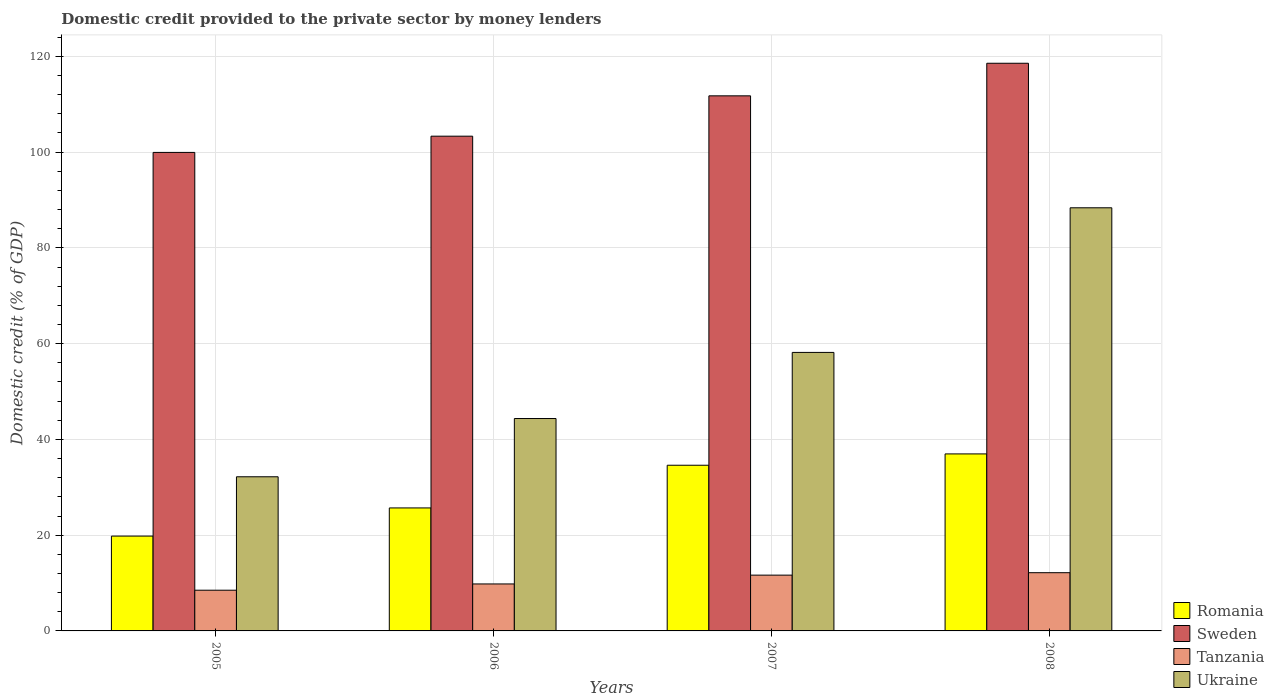How many groups of bars are there?
Your answer should be compact. 4. Are the number of bars per tick equal to the number of legend labels?
Keep it short and to the point. Yes. Are the number of bars on each tick of the X-axis equal?
Give a very brief answer. Yes. How many bars are there on the 4th tick from the right?
Your answer should be very brief. 4. What is the label of the 1st group of bars from the left?
Offer a very short reply. 2005. What is the domestic credit provided to the private sector by money lenders in Sweden in 2008?
Provide a succinct answer. 118.57. Across all years, what is the maximum domestic credit provided to the private sector by money lenders in Tanzania?
Offer a terse response. 12.16. Across all years, what is the minimum domestic credit provided to the private sector by money lenders in Ukraine?
Give a very brief answer. 32.2. In which year was the domestic credit provided to the private sector by money lenders in Romania minimum?
Offer a very short reply. 2005. What is the total domestic credit provided to the private sector by money lenders in Romania in the graph?
Give a very brief answer. 117.07. What is the difference between the domestic credit provided to the private sector by money lenders in Tanzania in 2005 and that in 2007?
Make the answer very short. -3.15. What is the difference between the domestic credit provided to the private sector by money lenders in Sweden in 2008 and the domestic credit provided to the private sector by money lenders in Romania in 2006?
Provide a succinct answer. 92.88. What is the average domestic credit provided to the private sector by money lenders in Sweden per year?
Provide a short and direct response. 108.4. In the year 2006, what is the difference between the domestic credit provided to the private sector by money lenders in Romania and domestic credit provided to the private sector by money lenders in Ukraine?
Provide a succinct answer. -18.68. In how many years, is the domestic credit provided to the private sector by money lenders in Romania greater than 80 %?
Offer a very short reply. 0. What is the ratio of the domestic credit provided to the private sector by money lenders in Romania in 2005 to that in 2008?
Ensure brevity in your answer.  0.54. Is the difference between the domestic credit provided to the private sector by money lenders in Romania in 2005 and 2006 greater than the difference between the domestic credit provided to the private sector by money lenders in Ukraine in 2005 and 2006?
Your answer should be very brief. Yes. What is the difference between the highest and the second highest domestic credit provided to the private sector by money lenders in Romania?
Your answer should be very brief. 2.37. What is the difference between the highest and the lowest domestic credit provided to the private sector by money lenders in Romania?
Provide a short and direct response. 17.16. Is it the case that in every year, the sum of the domestic credit provided to the private sector by money lenders in Sweden and domestic credit provided to the private sector by money lenders in Romania is greater than the sum of domestic credit provided to the private sector by money lenders in Ukraine and domestic credit provided to the private sector by money lenders in Tanzania?
Offer a terse response. Yes. What does the 1st bar from the left in 2005 represents?
Provide a short and direct response. Romania. What does the 4th bar from the right in 2006 represents?
Offer a very short reply. Romania. Is it the case that in every year, the sum of the domestic credit provided to the private sector by money lenders in Romania and domestic credit provided to the private sector by money lenders in Tanzania is greater than the domestic credit provided to the private sector by money lenders in Ukraine?
Offer a terse response. No. Are the values on the major ticks of Y-axis written in scientific E-notation?
Provide a short and direct response. No. Does the graph contain grids?
Offer a very short reply. Yes. Where does the legend appear in the graph?
Make the answer very short. Bottom right. How many legend labels are there?
Ensure brevity in your answer.  4. How are the legend labels stacked?
Provide a short and direct response. Vertical. What is the title of the graph?
Ensure brevity in your answer.  Domestic credit provided to the private sector by money lenders. Does "Japan" appear as one of the legend labels in the graph?
Your answer should be compact. No. What is the label or title of the X-axis?
Provide a succinct answer. Years. What is the label or title of the Y-axis?
Ensure brevity in your answer.  Domestic credit (% of GDP). What is the Domestic credit (% of GDP) in Romania in 2005?
Provide a short and direct response. 19.81. What is the Domestic credit (% of GDP) in Sweden in 2005?
Offer a very short reply. 99.95. What is the Domestic credit (% of GDP) in Tanzania in 2005?
Give a very brief answer. 8.5. What is the Domestic credit (% of GDP) of Ukraine in 2005?
Offer a terse response. 32.2. What is the Domestic credit (% of GDP) of Romania in 2006?
Offer a terse response. 25.69. What is the Domestic credit (% of GDP) in Sweden in 2006?
Offer a terse response. 103.33. What is the Domestic credit (% of GDP) in Tanzania in 2006?
Your response must be concise. 9.81. What is the Domestic credit (% of GDP) in Ukraine in 2006?
Your response must be concise. 44.36. What is the Domestic credit (% of GDP) in Romania in 2007?
Your response must be concise. 34.6. What is the Domestic credit (% of GDP) of Sweden in 2007?
Offer a terse response. 111.76. What is the Domestic credit (% of GDP) in Tanzania in 2007?
Make the answer very short. 11.65. What is the Domestic credit (% of GDP) in Ukraine in 2007?
Make the answer very short. 58.17. What is the Domestic credit (% of GDP) of Romania in 2008?
Give a very brief answer. 36.97. What is the Domestic credit (% of GDP) of Sweden in 2008?
Give a very brief answer. 118.57. What is the Domestic credit (% of GDP) of Tanzania in 2008?
Provide a short and direct response. 12.16. What is the Domestic credit (% of GDP) in Ukraine in 2008?
Make the answer very short. 88.38. Across all years, what is the maximum Domestic credit (% of GDP) in Romania?
Offer a terse response. 36.97. Across all years, what is the maximum Domestic credit (% of GDP) in Sweden?
Provide a succinct answer. 118.57. Across all years, what is the maximum Domestic credit (% of GDP) in Tanzania?
Your answer should be compact. 12.16. Across all years, what is the maximum Domestic credit (% of GDP) of Ukraine?
Offer a very short reply. 88.38. Across all years, what is the minimum Domestic credit (% of GDP) in Romania?
Ensure brevity in your answer.  19.81. Across all years, what is the minimum Domestic credit (% of GDP) in Sweden?
Keep it short and to the point. 99.95. Across all years, what is the minimum Domestic credit (% of GDP) of Tanzania?
Make the answer very short. 8.5. Across all years, what is the minimum Domestic credit (% of GDP) in Ukraine?
Offer a very short reply. 32.2. What is the total Domestic credit (% of GDP) of Romania in the graph?
Your answer should be compact. 117.07. What is the total Domestic credit (% of GDP) in Sweden in the graph?
Offer a terse response. 433.61. What is the total Domestic credit (% of GDP) of Tanzania in the graph?
Make the answer very short. 42.13. What is the total Domestic credit (% of GDP) of Ukraine in the graph?
Keep it short and to the point. 223.11. What is the difference between the Domestic credit (% of GDP) of Romania in 2005 and that in 2006?
Make the answer very short. -5.88. What is the difference between the Domestic credit (% of GDP) of Sweden in 2005 and that in 2006?
Give a very brief answer. -3.39. What is the difference between the Domestic credit (% of GDP) of Tanzania in 2005 and that in 2006?
Provide a short and direct response. -1.31. What is the difference between the Domestic credit (% of GDP) in Ukraine in 2005 and that in 2006?
Keep it short and to the point. -12.17. What is the difference between the Domestic credit (% of GDP) of Romania in 2005 and that in 2007?
Your response must be concise. -14.8. What is the difference between the Domestic credit (% of GDP) in Sweden in 2005 and that in 2007?
Provide a short and direct response. -11.82. What is the difference between the Domestic credit (% of GDP) of Tanzania in 2005 and that in 2007?
Your response must be concise. -3.15. What is the difference between the Domestic credit (% of GDP) in Ukraine in 2005 and that in 2007?
Offer a terse response. -25.97. What is the difference between the Domestic credit (% of GDP) of Romania in 2005 and that in 2008?
Provide a short and direct response. -17.16. What is the difference between the Domestic credit (% of GDP) of Sweden in 2005 and that in 2008?
Your response must be concise. -18.62. What is the difference between the Domestic credit (% of GDP) in Tanzania in 2005 and that in 2008?
Offer a very short reply. -3.66. What is the difference between the Domestic credit (% of GDP) in Ukraine in 2005 and that in 2008?
Provide a short and direct response. -56.18. What is the difference between the Domestic credit (% of GDP) in Romania in 2006 and that in 2007?
Offer a terse response. -8.92. What is the difference between the Domestic credit (% of GDP) in Sweden in 2006 and that in 2007?
Your answer should be very brief. -8.43. What is the difference between the Domestic credit (% of GDP) of Tanzania in 2006 and that in 2007?
Provide a short and direct response. -1.84. What is the difference between the Domestic credit (% of GDP) in Ukraine in 2006 and that in 2007?
Offer a very short reply. -13.81. What is the difference between the Domestic credit (% of GDP) in Romania in 2006 and that in 2008?
Your answer should be very brief. -11.29. What is the difference between the Domestic credit (% of GDP) in Sweden in 2006 and that in 2008?
Your answer should be compact. -15.23. What is the difference between the Domestic credit (% of GDP) of Tanzania in 2006 and that in 2008?
Provide a short and direct response. -2.35. What is the difference between the Domestic credit (% of GDP) in Ukraine in 2006 and that in 2008?
Offer a very short reply. -44.02. What is the difference between the Domestic credit (% of GDP) in Romania in 2007 and that in 2008?
Provide a short and direct response. -2.37. What is the difference between the Domestic credit (% of GDP) of Sweden in 2007 and that in 2008?
Make the answer very short. -6.81. What is the difference between the Domestic credit (% of GDP) of Tanzania in 2007 and that in 2008?
Make the answer very short. -0.51. What is the difference between the Domestic credit (% of GDP) of Ukraine in 2007 and that in 2008?
Your response must be concise. -30.21. What is the difference between the Domestic credit (% of GDP) in Romania in 2005 and the Domestic credit (% of GDP) in Sweden in 2006?
Your response must be concise. -83.53. What is the difference between the Domestic credit (% of GDP) in Romania in 2005 and the Domestic credit (% of GDP) in Tanzania in 2006?
Your response must be concise. 10. What is the difference between the Domestic credit (% of GDP) in Romania in 2005 and the Domestic credit (% of GDP) in Ukraine in 2006?
Make the answer very short. -24.55. What is the difference between the Domestic credit (% of GDP) in Sweden in 2005 and the Domestic credit (% of GDP) in Tanzania in 2006?
Make the answer very short. 90.13. What is the difference between the Domestic credit (% of GDP) of Sweden in 2005 and the Domestic credit (% of GDP) of Ukraine in 2006?
Provide a succinct answer. 55.58. What is the difference between the Domestic credit (% of GDP) of Tanzania in 2005 and the Domestic credit (% of GDP) of Ukraine in 2006?
Your response must be concise. -35.86. What is the difference between the Domestic credit (% of GDP) in Romania in 2005 and the Domestic credit (% of GDP) in Sweden in 2007?
Make the answer very short. -91.95. What is the difference between the Domestic credit (% of GDP) of Romania in 2005 and the Domestic credit (% of GDP) of Tanzania in 2007?
Give a very brief answer. 8.16. What is the difference between the Domestic credit (% of GDP) in Romania in 2005 and the Domestic credit (% of GDP) in Ukraine in 2007?
Your answer should be compact. -38.36. What is the difference between the Domestic credit (% of GDP) of Sweden in 2005 and the Domestic credit (% of GDP) of Tanzania in 2007?
Provide a succinct answer. 88.29. What is the difference between the Domestic credit (% of GDP) of Sweden in 2005 and the Domestic credit (% of GDP) of Ukraine in 2007?
Your answer should be compact. 41.78. What is the difference between the Domestic credit (% of GDP) in Tanzania in 2005 and the Domestic credit (% of GDP) in Ukraine in 2007?
Make the answer very short. -49.67. What is the difference between the Domestic credit (% of GDP) of Romania in 2005 and the Domestic credit (% of GDP) of Sweden in 2008?
Make the answer very short. -98.76. What is the difference between the Domestic credit (% of GDP) in Romania in 2005 and the Domestic credit (% of GDP) in Tanzania in 2008?
Your response must be concise. 7.65. What is the difference between the Domestic credit (% of GDP) of Romania in 2005 and the Domestic credit (% of GDP) of Ukraine in 2008?
Your response must be concise. -68.57. What is the difference between the Domestic credit (% of GDP) in Sweden in 2005 and the Domestic credit (% of GDP) in Tanzania in 2008?
Offer a very short reply. 87.78. What is the difference between the Domestic credit (% of GDP) in Sweden in 2005 and the Domestic credit (% of GDP) in Ukraine in 2008?
Offer a very short reply. 11.57. What is the difference between the Domestic credit (% of GDP) in Tanzania in 2005 and the Domestic credit (% of GDP) in Ukraine in 2008?
Provide a short and direct response. -79.87. What is the difference between the Domestic credit (% of GDP) of Romania in 2006 and the Domestic credit (% of GDP) of Sweden in 2007?
Your answer should be compact. -86.07. What is the difference between the Domestic credit (% of GDP) in Romania in 2006 and the Domestic credit (% of GDP) in Tanzania in 2007?
Your answer should be compact. 14.04. What is the difference between the Domestic credit (% of GDP) in Romania in 2006 and the Domestic credit (% of GDP) in Ukraine in 2007?
Offer a very short reply. -32.48. What is the difference between the Domestic credit (% of GDP) of Sweden in 2006 and the Domestic credit (% of GDP) of Tanzania in 2007?
Provide a short and direct response. 91.68. What is the difference between the Domestic credit (% of GDP) in Sweden in 2006 and the Domestic credit (% of GDP) in Ukraine in 2007?
Ensure brevity in your answer.  45.17. What is the difference between the Domestic credit (% of GDP) in Tanzania in 2006 and the Domestic credit (% of GDP) in Ukraine in 2007?
Offer a terse response. -48.36. What is the difference between the Domestic credit (% of GDP) of Romania in 2006 and the Domestic credit (% of GDP) of Sweden in 2008?
Make the answer very short. -92.88. What is the difference between the Domestic credit (% of GDP) in Romania in 2006 and the Domestic credit (% of GDP) in Tanzania in 2008?
Provide a short and direct response. 13.53. What is the difference between the Domestic credit (% of GDP) in Romania in 2006 and the Domestic credit (% of GDP) in Ukraine in 2008?
Give a very brief answer. -62.69. What is the difference between the Domestic credit (% of GDP) of Sweden in 2006 and the Domestic credit (% of GDP) of Tanzania in 2008?
Keep it short and to the point. 91.17. What is the difference between the Domestic credit (% of GDP) in Sweden in 2006 and the Domestic credit (% of GDP) in Ukraine in 2008?
Make the answer very short. 14.96. What is the difference between the Domestic credit (% of GDP) in Tanzania in 2006 and the Domestic credit (% of GDP) in Ukraine in 2008?
Keep it short and to the point. -78.57. What is the difference between the Domestic credit (% of GDP) in Romania in 2007 and the Domestic credit (% of GDP) in Sweden in 2008?
Make the answer very short. -83.96. What is the difference between the Domestic credit (% of GDP) of Romania in 2007 and the Domestic credit (% of GDP) of Tanzania in 2008?
Your answer should be compact. 22.44. What is the difference between the Domestic credit (% of GDP) in Romania in 2007 and the Domestic credit (% of GDP) in Ukraine in 2008?
Ensure brevity in your answer.  -53.77. What is the difference between the Domestic credit (% of GDP) of Sweden in 2007 and the Domestic credit (% of GDP) of Tanzania in 2008?
Your answer should be very brief. 99.6. What is the difference between the Domestic credit (% of GDP) in Sweden in 2007 and the Domestic credit (% of GDP) in Ukraine in 2008?
Offer a terse response. 23.38. What is the difference between the Domestic credit (% of GDP) in Tanzania in 2007 and the Domestic credit (% of GDP) in Ukraine in 2008?
Provide a short and direct response. -76.73. What is the average Domestic credit (% of GDP) of Romania per year?
Your answer should be very brief. 29.27. What is the average Domestic credit (% of GDP) in Sweden per year?
Your answer should be compact. 108.4. What is the average Domestic credit (% of GDP) of Tanzania per year?
Your answer should be very brief. 10.53. What is the average Domestic credit (% of GDP) of Ukraine per year?
Keep it short and to the point. 55.78. In the year 2005, what is the difference between the Domestic credit (% of GDP) in Romania and Domestic credit (% of GDP) in Sweden?
Offer a very short reply. -80.14. In the year 2005, what is the difference between the Domestic credit (% of GDP) in Romania and Domestic credit (% of GDP) in Tanzania?
Give a very brief answer. 11.3. In the year 2005, what is the difference between the Domestic credit (% of GDP) of Romania and Domestic credit (% of GDP) of Ukraine?
Ensure brevity in your answer.  -12.39. In the year 2005, what is the difference between the Domestic credit (% of GDP) of Sweden and Domestic credit (% of GDP) of Tanzania?
Keep it short and to the point. 91.44. In the year 2005, what is the difference between the Domestic credit (% of GDP) of Sweden and Domestic credit (% of GDP) of Ukraine?
Make the answer very short. 67.75. In the year 2005, what is the difference between the Domestic credit (% of GDP) in Tanzania and Domestic credit (% of GDP) in Ukraine?
Provide a succinct answer. -23.69. In the year 2006, what is the difference between the Domestic credit (% of GDP) in Romania and Domestic credit (% of GDP) in Sweden?
Offer a very short reply. -77.65. In the year 2006, what is the difference between the Domestic credit (% of GDP) in Romania and Domestic credit (% of GDP) in Tanzania?
Your answer should be compact. 15.88. In the year 2006, what is the difference between the Domestic credit (% of GDP) in Romania and Domestic credit (% of GDP) in Ukraine?
Your response must be concise. -18.68. In the year 2006, what is the difference between the Domestic credit (% of GDP) of Sweden and Domestic credit (% of GDP) of Tanzania?
Your answer should be very brief. 93.52. In the year 2006, what is the difference between the Domestic credit (% of GDP) of Sweden and Domestic credit (% of GDP) of Ukraine?
Offer a very short reply. 58.97. In the year 2006, what is the difference between the Domestic credit (% of GDP) in Tanzania and Domestic credit (% of GDP) in Ukraine?
Make the answer very short. -34.55. In the year 2007, what is the difference between the Domestic credit (% of GDP) in Romania and Domestic credit (% of GDP) in Sweden?
Your answer should be very brief. -77.16. In the year 2007, what is the difference between the Domestic credit (% of GDP) in Romania and Domestic credit (% of GDP) in Tanzania?
Your answer should be very brief. 22.95. In the year 2007, what is the difference between the Domestic credit (% of GDP) of Romania and Domestic credit (% of GDP) of Ukraine?
Your answer should be compact. -23.57. In the year 2007, what is the difference between the Domestic credit (% of GDP) of Sweden and Domestic credit (% of GDP) of Tanzania?
Keep it short and to the point. 100.11. In the year 2007, what is the difference between the Domestic credit (% of GDP) in Sweden and Domestic credit (% of GDP) in Ukraine?
Your response must be concise. 53.59. In the year 2007, what is the difference between the Domestic credit (% of GDP) of Tanzania and Domestic credit (% of GDP) of Ukraine?
Offer a terse response. -46.52. In the year 2008, what is the difference between the Domestic credit (% of GDP) of Romania and Domestic credit (% of GDP) of Sweden?
Offer a very short reply. -81.59. In the year 2008, what is the difference between the Domestic credit (% of GDP) in Romania and Domestic credit (% of GDP) in Tanzania?
Ensure brevity in your answer.  24.81. In the year 2008, what is the difference between the Domestic credit (% of GDP) of Romania and Domestic credit (% of GDP) of Ukraine?
Ensure brevity in your answer.  -51.41. In the year 2008, what is the difference between the Domestic credit (% of GDP) of Sweden and Domestic credit (% of GDP) of Tanzania?
Keep it short and to the point. 106.41. In the year 2008, what is the difference between the Domestic credit (% of GDP) in Sweden and Domestic credit (% of GDP) in Ukraine?
Keep it short and to the point. 30.19. In the year 2008, what is the difference between the Domestic credit (% of GDP) of Tanzania and Domestic credit (% of GDP) of Ukraine?
Ensure brevity in your answer.  -76.22. What is the ratio of the Domestic credit (% of GDP) in Romania in 2005 to that in 2006?
Make the answer very short. 0.77. What is the ratio of the Domestic credit (% of GDP) in Sweden in 2005 to that in 2006?
Ensure brevity in your answer.  0.97. What is the ratio of the Domestic credit (% of GDP) in Tanzania in 2005 to that in 2006?
Offer a very short reply. 0.87. What is the ratio of the Domestic credit (% of GDP) in Ukraine in 2005 to that in 2006?
Your answer should be compact. 0.73. What is the ratio of the Domestic credit (% of GDP) in Romania in 2005 to that in 2007?
Your answer should be compact. 0.57. What is the ratio of the Domestic credit (% of GDP) of Sweden in 2005 to that in 2007?
Your answer should be very brief. 0.89. What is the ratio of the Domestic credit (% of GDP) in Tanzania in 2005 to that in 2007?
Keep it short and to the point. 0.73. What is the ratio of the Domestic credit (% of GDP) in Ukraine in 2005 to that in 2007?
Make the answer very short. 0.55. What is the ratio of the Domestic credit (% of GDP) in Romania in 2005 to that in 2008?
Make the answer very short. 0.54. What is the ratio of the Domestic credit (% of GDP) of Sweden in 2005 to that in 2008?
Offer a very short reply. 0.84. What is the ratio of the Domestic credit (% of GDP) of Tanzania in 2005 to that in 2008?
Provide a succinct answer. 0.7. What is the ratio of the Domestic credit (% of GDP) of Ukraine in 2005 to that in 2008?
Offer a very short reply. 0.36. What is the ratio of the Domestic credit (% of GDP) of Romania in 2006 to that in 2007?
Your answer should be very brief. 0.74. What is the ratio of the Domestic credit (% of GDP) of Sweden in 2006 to that in 2007?
Make the answer very short. 0.92. What is the ratio of the Domestic credit (% of GDP) in Tanzania in 2006 to that in 2007?
Your answer should be very brief. 0.84. What is the ratio of the Domestic credit (% of GDP) in Ukraine in 2006 to that in 2007?
Offer a very short reply. 0.76. What is the ratio of the Domestic credit (% of GDP) in Romania in 2006 to that in 2008?
Give a very brief answer. 0.69. What is the ratio of the Domestic credit (% of GDP) of Sweden in 2006 to that in 2008?
Ensure brevity in your answer.  0.87. What is the ratio of the Domestic credit (% of GDP) of Tanzania in 2006 to that in 2008?
Ensure brevity in your answer.  0.81. What is the ratio of the Domestic credit (% of GDP) of Ukraine in 2006 to that in 2008?
Your answer should be very brief. 0.5. What is the ratio of the Domestic credit (% of GDP) of Romania in 2007 to that in 2008?
Your response must be concise. 0.94. What is the ratio of the Domestic credit (% of GDP) in Sweden in 2007 to that in 2008?
Your answer should be very brief. 0.94. What is the ratio of the Domestic credit (% of GDP) in Tanzania in 2007 to that in 2008?
Provide a succinct answer. 0.96. What is the ratio of the Domestic credit (% of GDP) of Ukraine in 2007 to that in 2008?
Your answer should be compact. 0.66. What is the difference between the highest and the second highest Domestic credit (% of GDP) of Romania?
Keep it short and to the point. 2.37. What is the difference between the highest and the second highest Domestic credit (% of GDP) of Sweden?
Provide a succinct answer. 6.81. What is the difference between the highest and the second highest Domestic credit (% of GDP) in Tanzania?
Provide a short and direct response. 0.51. What is the difference between the highest and the second highest Domestic credit (% of GDP) in Ukraine?
Offer a very short reply. 30.21. What is the difference between the highest and the lowest Domestic credit (% of GDP) in Romania?
Your answer should be compact. 17.16. What is the difference between the highest and the lowest Domestic credit (% of GDP) in Sweden?
Ensure brevity in your answer.  18.62. What is the difference between the highest and the lowest Domestic credit (% of GDP) in Tanzania?
Your response must be concise. 3.66. What is the difference between the highest and the lowest Domestic credit (% of GDP) of Ukraine?
Your answer should be compact. 56.18. 